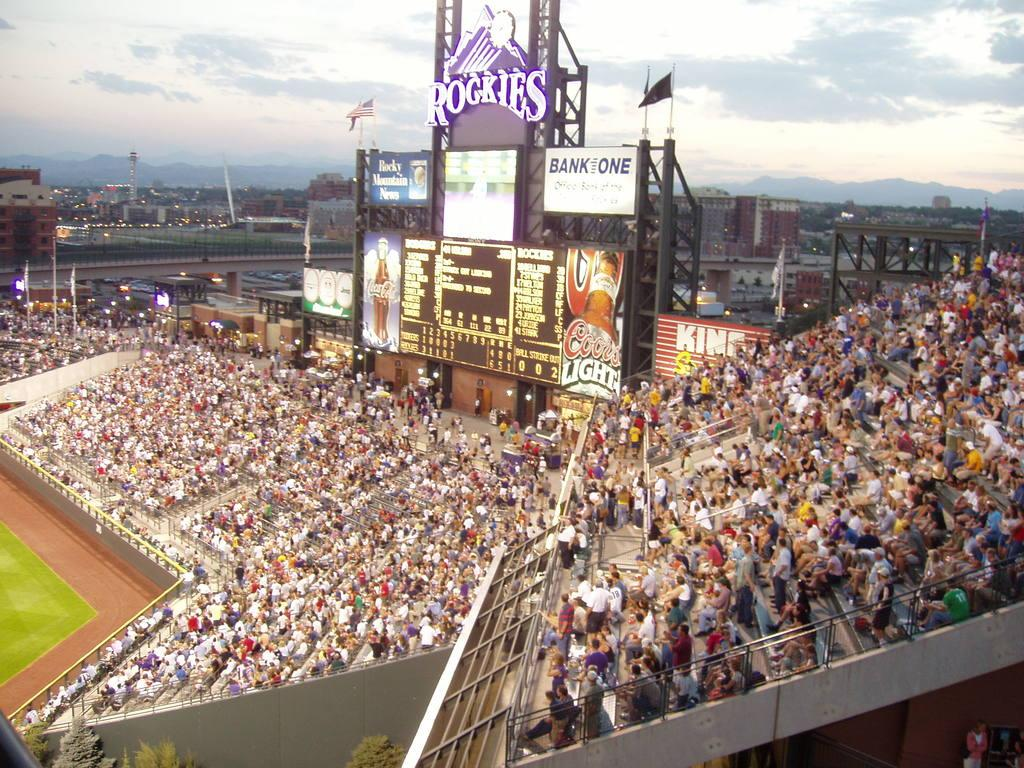<image>
Give a short and clear explanation of the subsequent image. A ballpark has a large scoreboard with Rockies on it. 